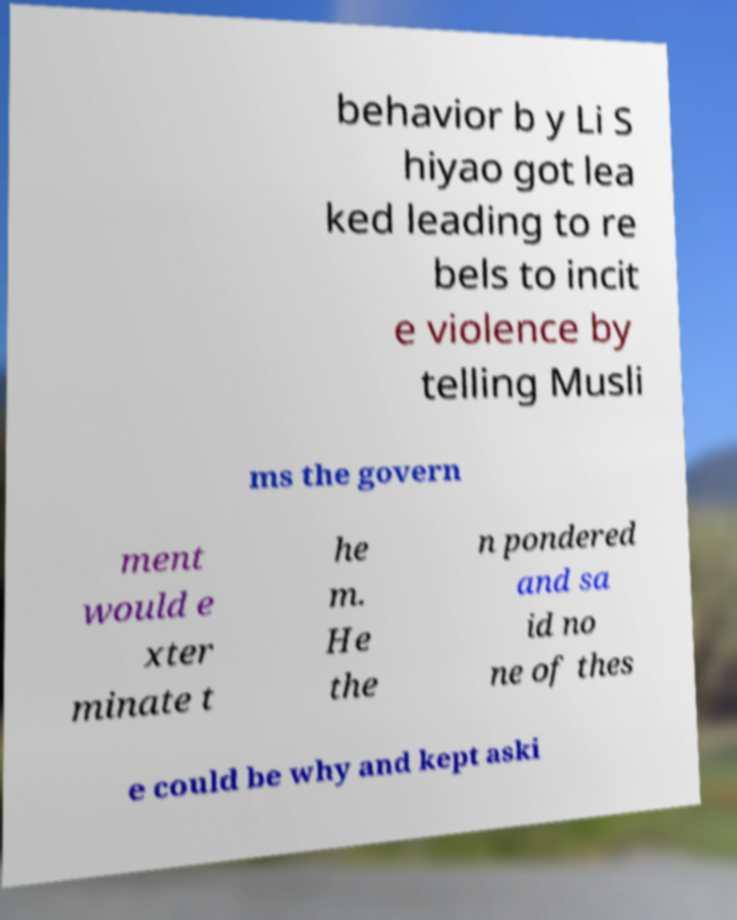Can you accurately transcribe the text from the provided image for me? behavior b y Li S hiyao got lea ked leading to re bels to incit e violence by telling Musli ms the govern ment would e xter minate t he m. He the n pondered and sa id no ne of thes e could be why and kept aski 